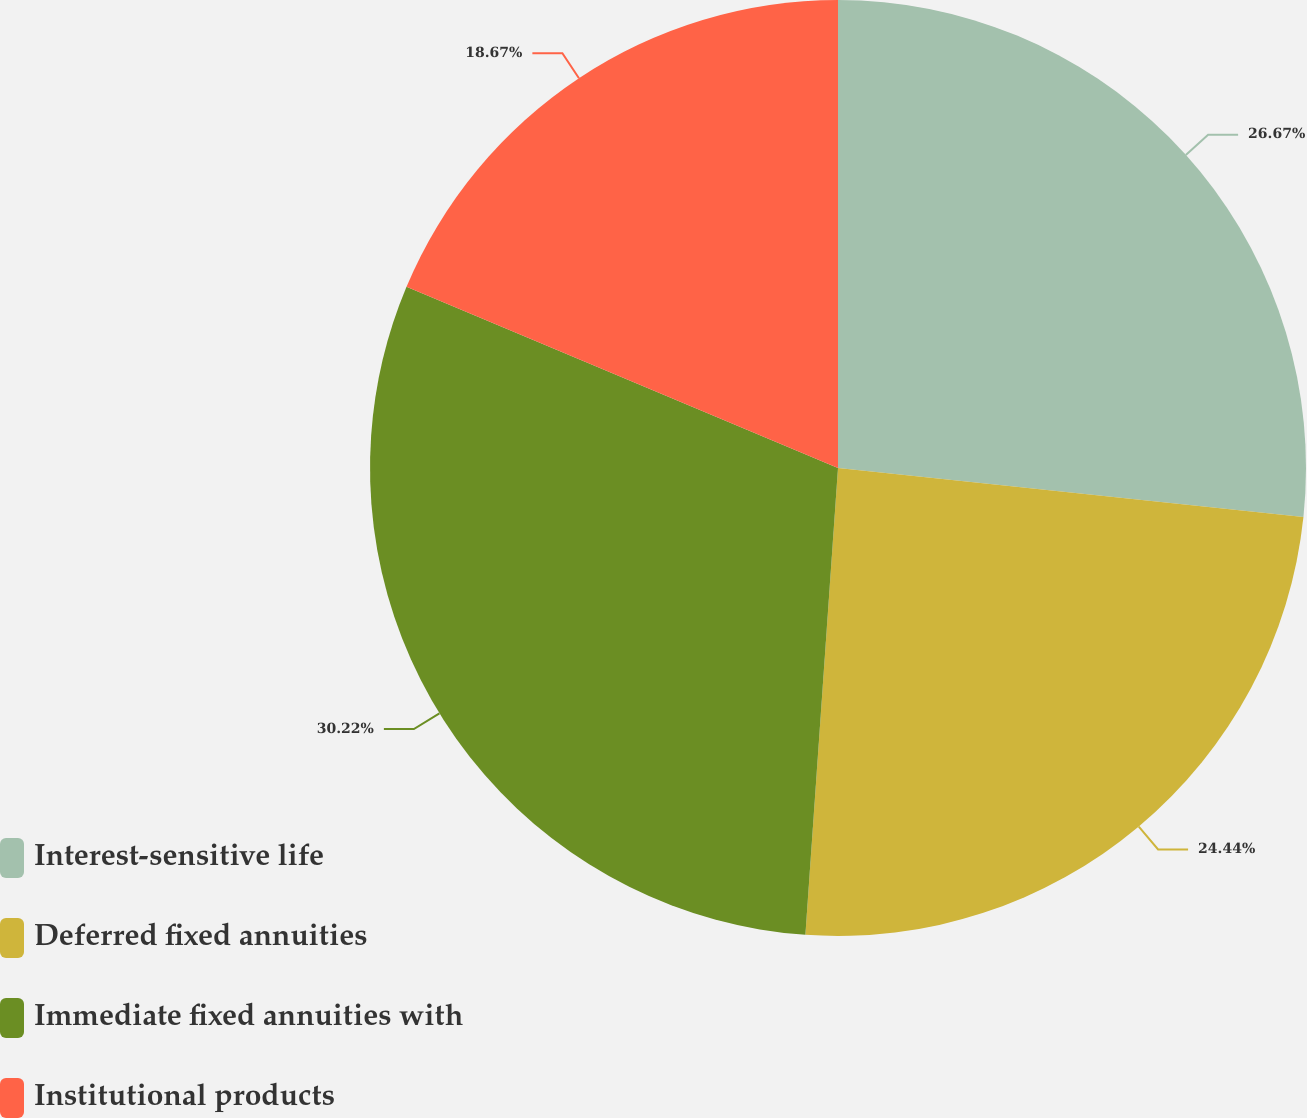<chart> <loc_0><loc_0><loc_500><loc_500><pie_chart><fcel>Interest-sensitive life<fcel>Deferred fixed annuities<fcel>Immediate fixed annuities with<fcel>Institutional products<nl><fcel>26.67%<fcel>24.44%<fcel>30.22%<fcel>18.67%<nl></chart> 